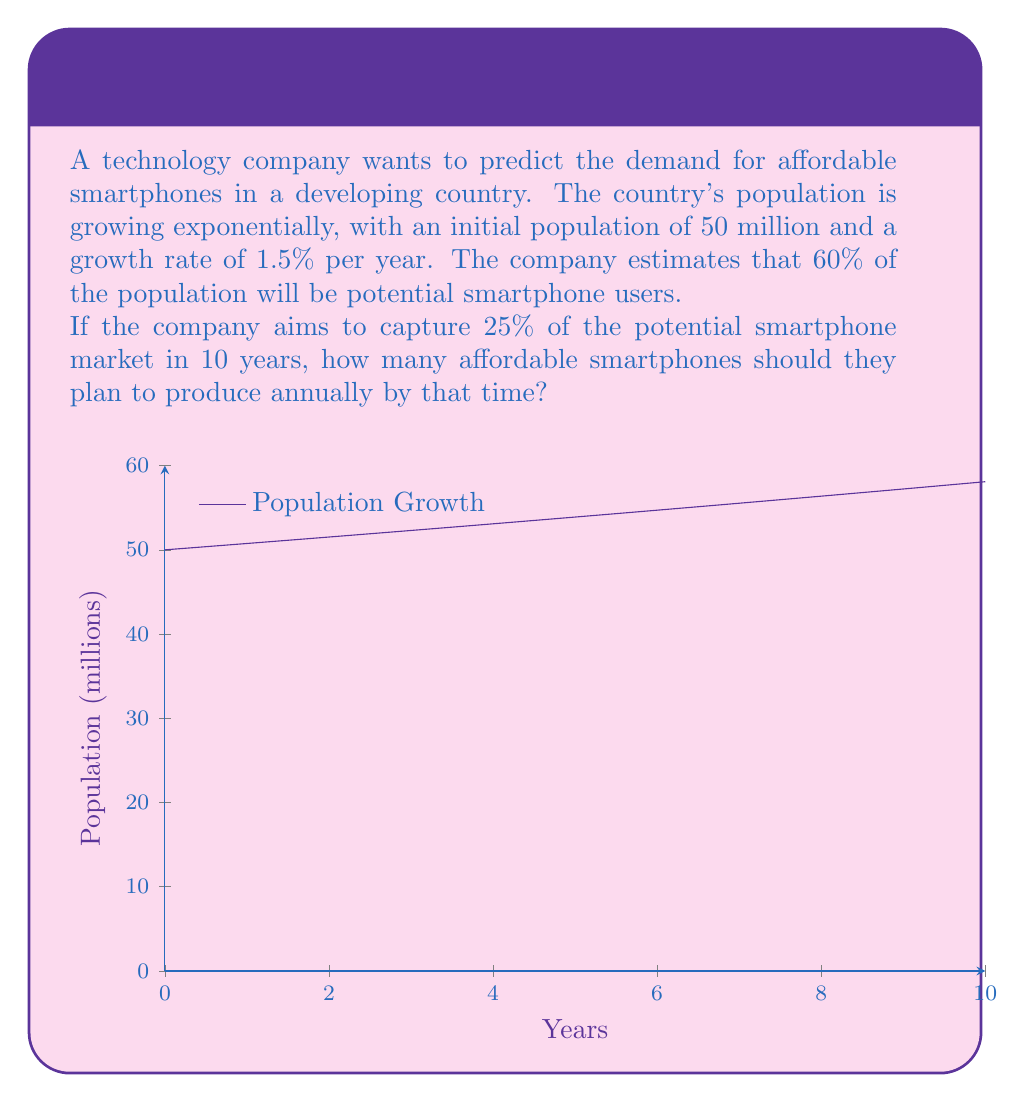Solve this math problem. Let's break this down step-by-step:

1) First, we need to calculate the population after 10 years. We can use the exponential growth formula:

   $P(t) = P_0 \cdot e^{rt}$

   Where:
   $P(t)$ is the population at time $t$
   $P_0$ is the initial population (50 million)
   $r$ is the growth rate (1.5% = 0.015)
   $t$ is the time in years (10)

2) Plugging in the values:

   $P(10) = 50 \cdot e^{0.015 \cdot 10} \approx 58.182$ million

3) Now, we need to calculate 60% of this population as potential smartphone users:

   $58.182 \cdot 0.60 \approx 34.909$ million potential users

4) The company aims to capture 25% of this market:

   $34.909 \cdot 0.25 \approx 8.727$ million users

5) This is the total number of users after 10 years. To find the annual production, we divide by 10:

   $8.727 \div 10 \approx 0.8727$ million smartphones per year

6) Converting to a whole number:

   $0.8727 \cdot 1,000,000 \approx 872,700$ smartphones per year
Answer: 872,700 smartphones per year 